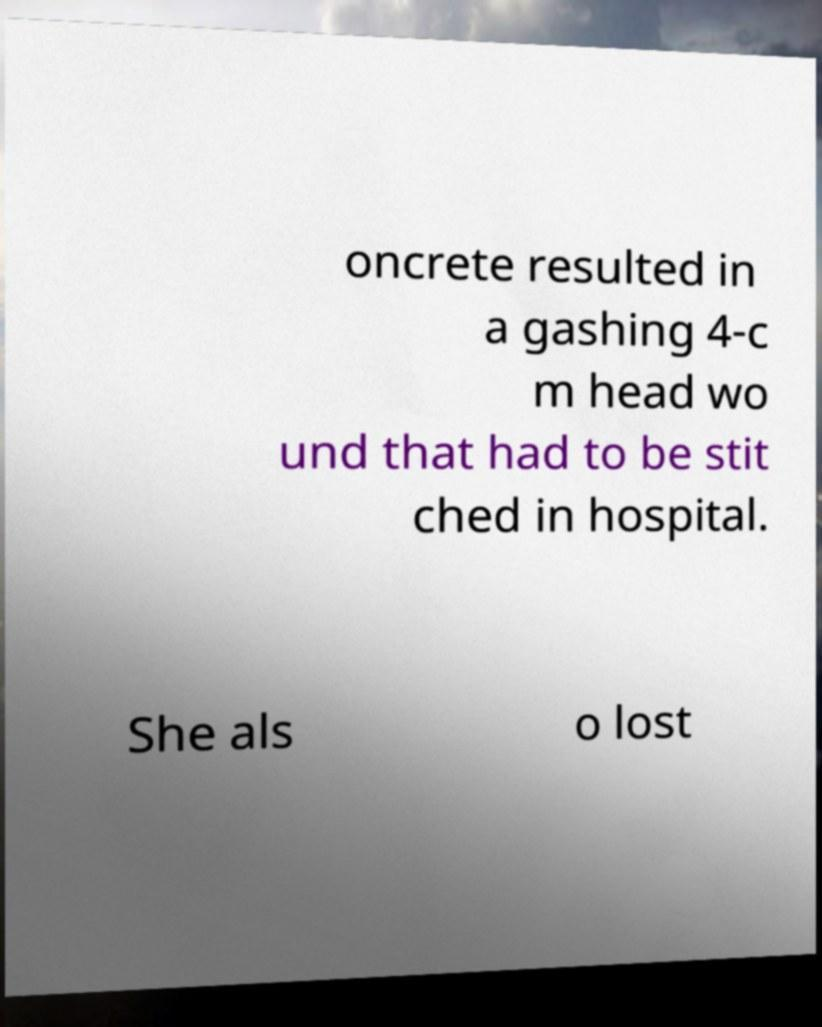For documentation purposes, I need the text within this image transcribed. Could you provide that? oncrete resulted in a gashing 4-c m head wo und that had to be stit ched in hospital. She als o lost 